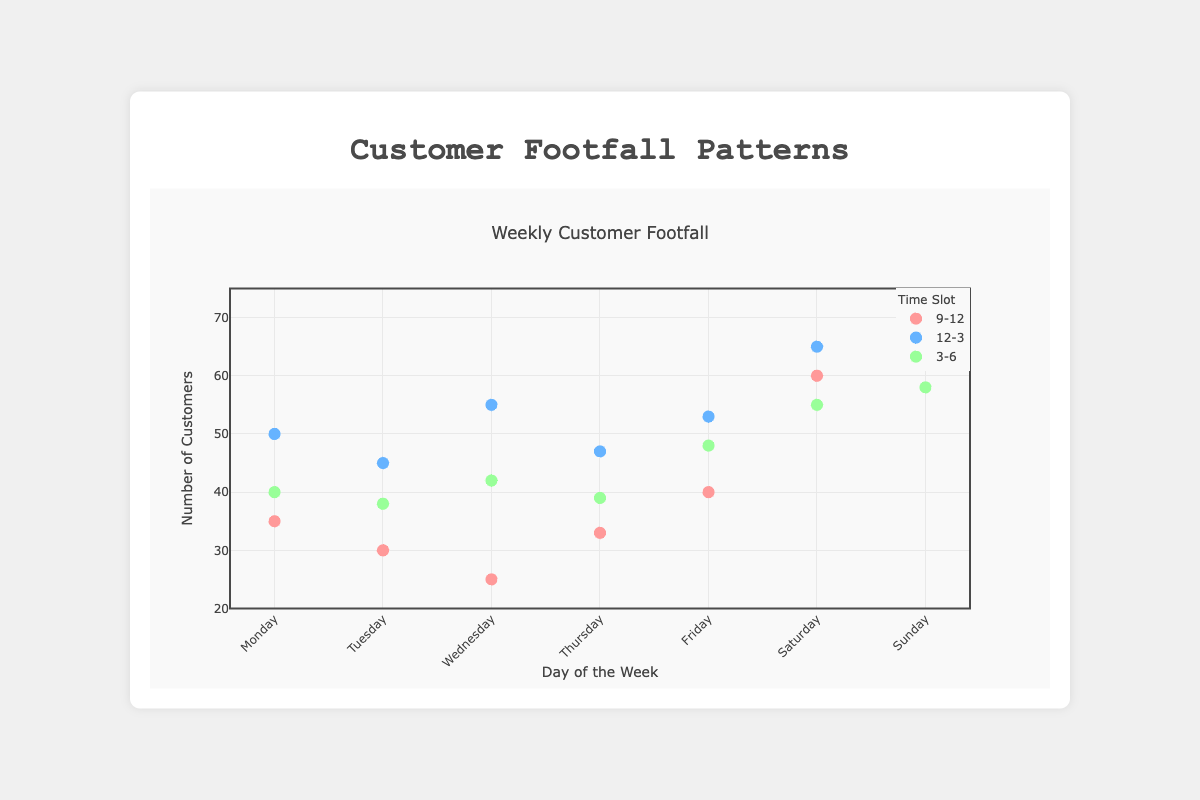What is the title of the chart? The title is displayed at the top of the chart, indicating the main subject of the figure.
Answer: Weekly Customer Footfall Which day has the highest number of customers during the 12-3 time slot? Look at the y-values for the 12-3 series (blue markers) and identify the peak value. The highest value is 70 on Sunday.
Answer: Sunday How many customers visited on Tuesday between 9-12? Refer to the y-value associated with the 'Tuesday' label under the '9-12' time slot series (red markers). The value is 30.
Answer: 30 On which days do the 9-12 and 12-3 time slots have equal customer footfall? Compare the y-values for the red and blue markers across all days and find where they match. None of the days have equal values.
Answer: None What is the total number of customers on Wednesday? Sum the y-values of all time slots for Wednesday: 25 (9-12) + 55 (12-3) + 42 (3-6). The total is 122.
Answer: 122 Which time slot generally has the lowest footfall during weekdays? Compare the y-values for the '9-12', '12-3', and '3-6' series across Monday to Friday. The '9-12' time slot usually has the lowest values.
Answer: 9-12 During which time slot does Saturday have the highest customer footfall? Focus on the y-values of Saturday across all time slots and identify the peak. The highest value is 65 during the '12-3' slot.
Answer: 12-3 What is the average customer footfall for the 3-6 time slot across all days? Add the y-values for the '3-6' series (green markers) for all days and divide by 7: (40+38+42+39+48+55+58)/7. The average is around 45.7.
Answer: 45.7 Which day has the lowest number of customers between 3-6? Identify the minimum y-value for the '3-6' series (green markers). The lowest value is 38 on Tuesday.
Answer: Tuesday 